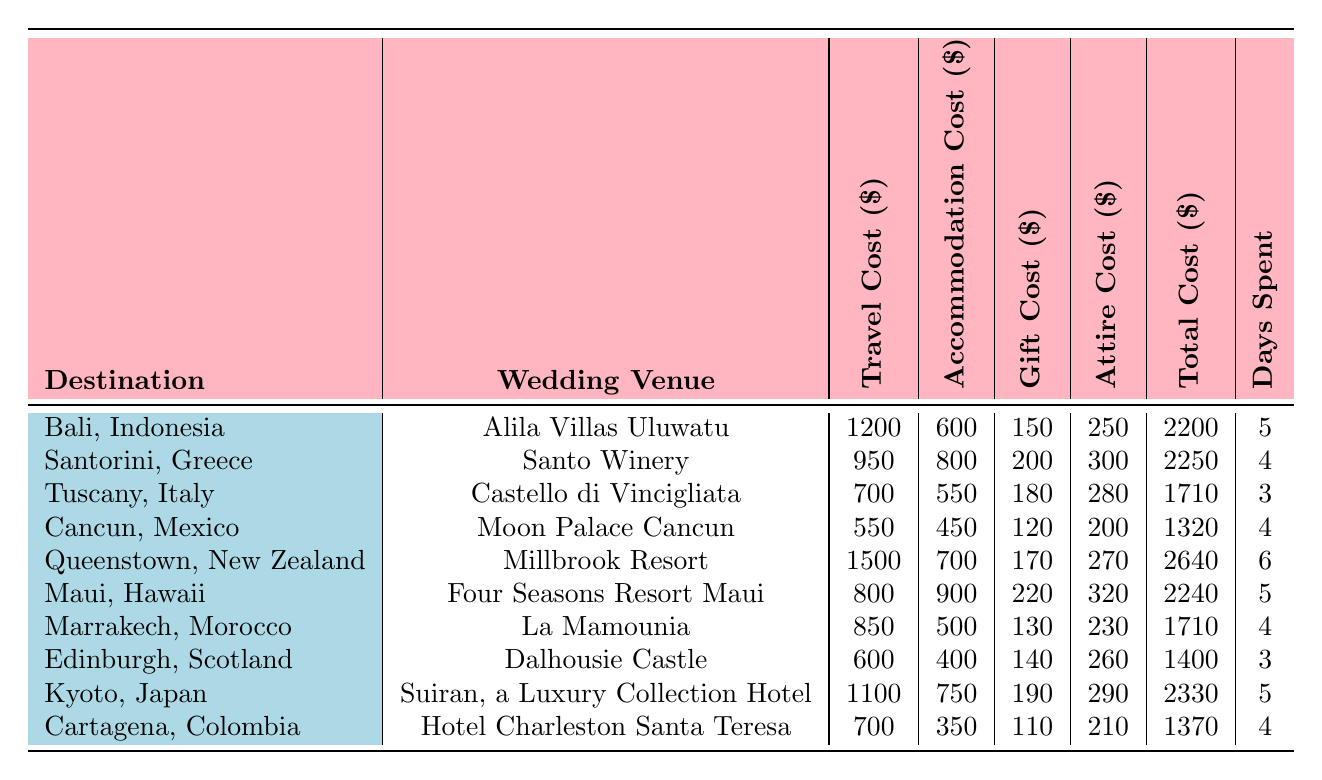What is the total cost of attending a wedding in Cancun, Mexico? From the table, the total cost for Cancun, Mexico is directly provided in the "Total Cost" column, which shows $1320.
Answer: 1320 How much does it cost to travel to Bali, Indonesia? The table lists the travel cost for Bali, Indonesia as $1200 in the "Travel Cost" column.
Answer: 1200 Which destination has the highest total cost for attending a wedding? By comparing the total costs listed in the "Total Cost" column, Queenstown, New Zealand has the highest at $2640.
Answer: Queenstown, New Zealand What is the average accommodation cost across all listed destinations? To find the average, sum all accommodation costs: (600 + 800 + 550 + 450 + 700 + 900 + 500 + 400 + 750 + 350) = 5250. There are 10 destinations, so the average is 5250 / 10 = 525.
Answer: 525 Is the gift cost for the wedding in Santorini, Greece greater than the gift cost in Marrakech, Morocco? The gift cost for Santorini is $200 and for Marrakech it is $130. Since $200 > $130, the statement is true.
Answer: Yes What is the total cost difference between attending a wedding in Kyoto, Japan and Tuscany, Italy? The total cost for Kyoto is $2330 and for Tuscany is $1710. The difference is $2330 - $1710 = $620.
Answer: 620 In how many days did the traveler spend attending the wedding in Queenstown, New Zealand? The table states that the days spent in Queenstown, New Zealand are 6, as seen in the "Days Spent" column.
Answer: 6 Which destination has the least travel cost? By checking the "Travel Cost" column, Cancun has the lowest travel cost of $550 compared to other destinations.
Answer: Cancun, Mexico What would be the total cost of attending a wedding in both Cancun, Mexico and Edinburgh, Scotland? The total cost for Cancun is $1320 and for Edinburgh is $1400. Adding these together gives $1320 + $1400 = $2720.
Answer: 2720 Is the combined travel and accommodation cost for attending a wedding in Maui, Hawaii greater than $1700? The travel cost for Maui is $800 and the accommodation is $900, which sums to $1700. Since it is not greater, the answer is false.
Answer: No 